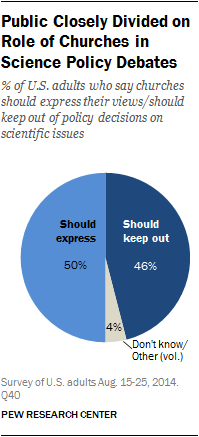Highlight a few significant elements in this photo. The color of the largest segment is light blue, and it is. We take the difference between the two largest segments, multiply it by the smallest segment, and the result is 16. 